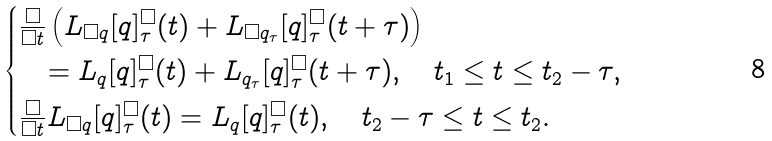Convert formula to latex. <formula><loc_0><loc_0><loc_500><loc_500>\begin{cases} \frac { \square } { \square t } \left ( L _ { \square q } [ q ] _ { \tau } ^ { \square } ( t ) + L _ { \square q _ { \tau } } [ q ] _ { \tau } ^ { \square } ( t + \tau ) \right ) \\ \quad = L _ { q } [ q ] _ { \tau } ^ { \square } ( t ) + L _ { q _ { \tau } } [ q ] _ { \tau } ^ { \square } ( t + \tau ) , \quad t _ { 1 } \leq t \leq t _ { 2 } - \tau , \\ \frac { \square } { \square t } L _ { \square q } [ q ] _ { \tau } ^ { \square } ( t ) = L _ { q } [ q ] _ { \tau } ^ { \square } ( t ) , \quad t _ { 2 } - \tau \leq t \leq t _ { 2 } . \end{cases}</formula> 